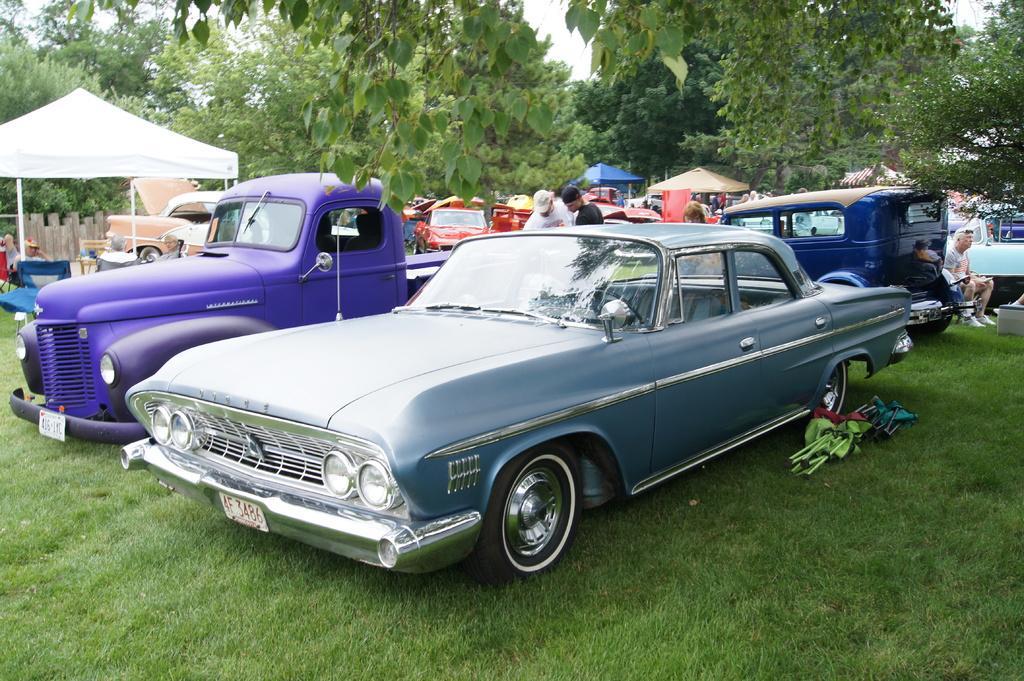In one or two sentences, can you explain what this image depicts? Here we can see vehicles, grass, tents, trees and people. 